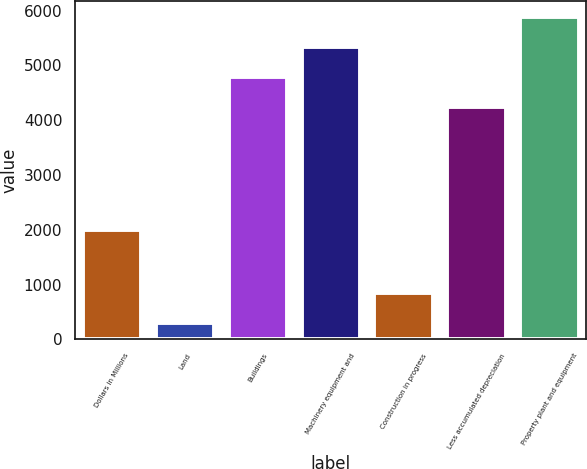Convert chart to OTSL. <chart><loc_0><loc_0><loc_500><loc_500><bar_chart><fcel>Dollars in Millions<fcel>Land<fcel>Buildings<fcel>Machinery equipment and<fcel>Construction in progress<fcel>Less accumulated depreciation<fcel>Property plant and equipment<nl><fcel>2004<fcel>290<fcel>4791.5<fcel>5339<fcel>837.5<fcel>4244<fcel>5886.5<nl></chart> 